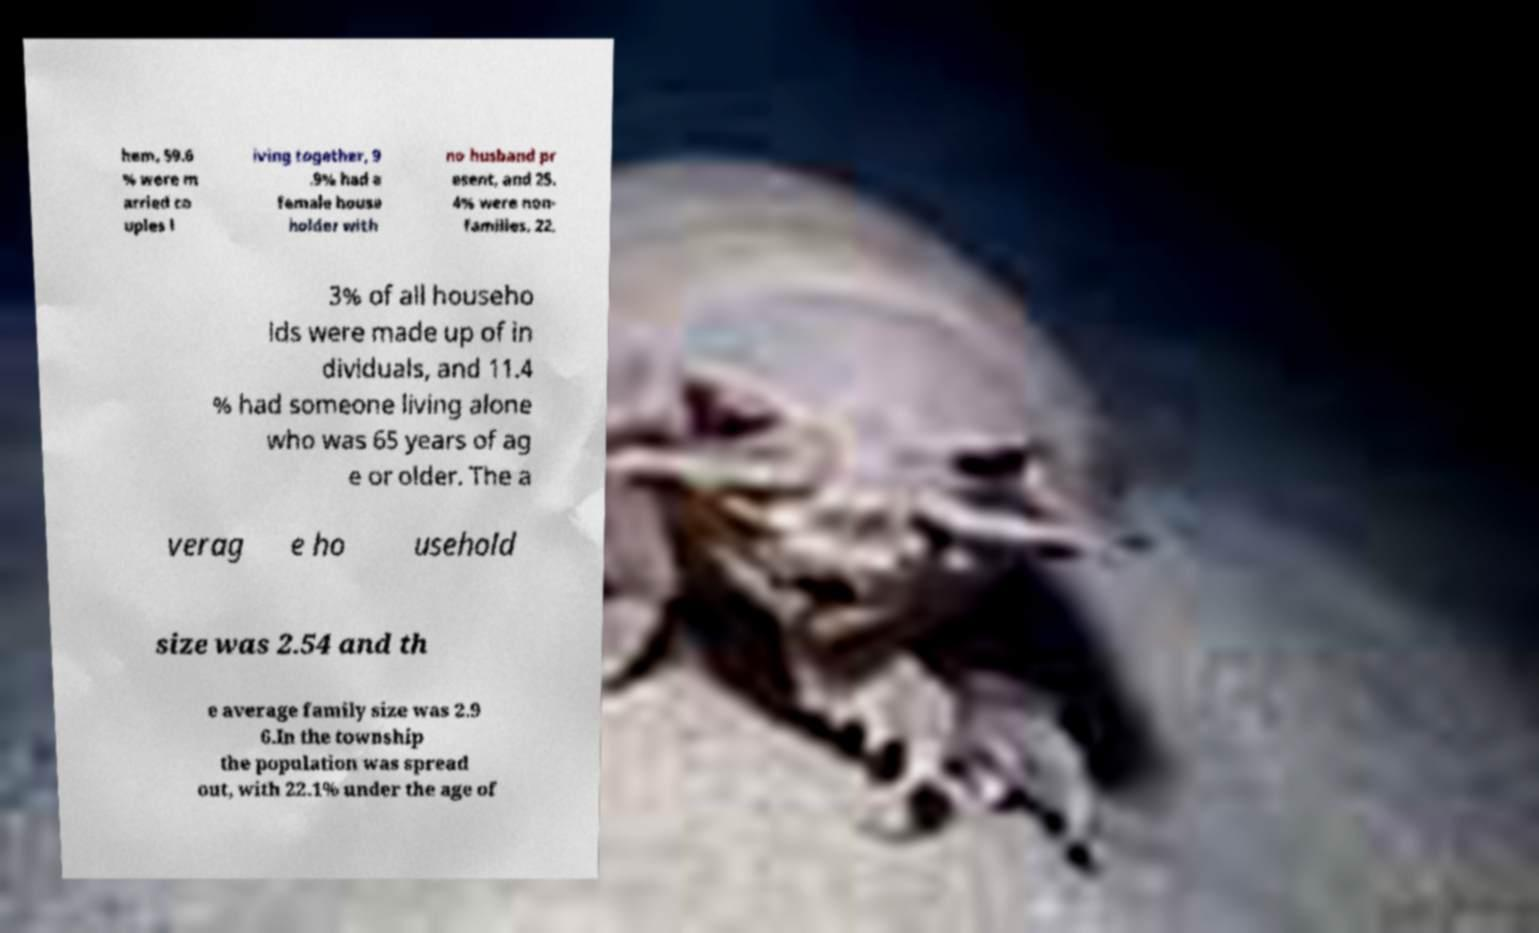For documentation purposes, I need the text within this image transcribed. Could you provide that? hem, 59.6 % were m arried co uples l iving together, 9 .9% had a female house holder with no husband pr esent, and 25. 4% were non- families. 22. 3% of all househo lds were made up of in dividuals, and 11.4 % had someone living alone who was 65 years of ag e or older. The a verag e ho usehold size was 2.54 and th e average family size was 2.9 6.In the township the population was spread out, with 22.1% under the age of 